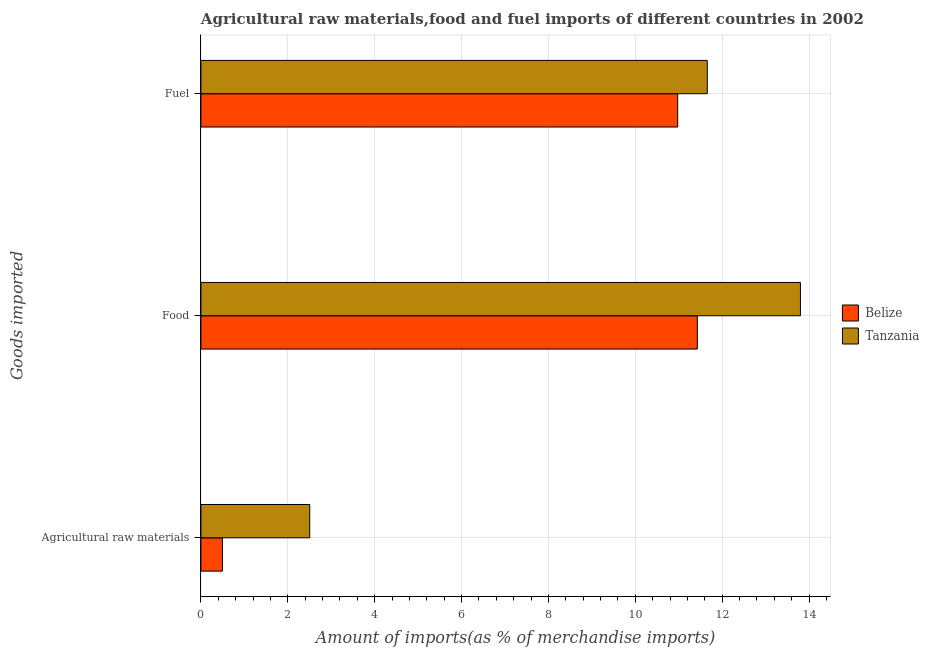Are the number of bars per tick equal to the number of legend labels?
Provide a succinct answer. Yes. How many bars are there on the 1st tick from the top?
Give a very brief answer. 2. How many bars are there on the 1st tick from the bottom?
Offer a terse response. 2. What is the label of the 2nd group of bars from the top?
Keep it short and to the point. Food. What is the percentage of fuel imports in Belize?
Ensure brevity in your answer.  10.98. Across all countries, what is the maximum percentage of food imports?
Make the answer very short. 13.8. Across all countries, what is the minimum percentage of raw materials imports?
Your answer should be very brief. 0.5. In which country was the percentage of raw materials imports maximum?
Make the answer very short. Tanzania. In which country was the percentage of food imports minimum?
Give a very brief answer. Belize. What is the total percentage of fuel imports in the graph?
Your answer should be compact. 22.63. What is the difference between the percentage of food imports in Belize and that in Tanzania?
Keep it short and to the point. -2.37. What is the difference between the percentage of food imports in Belize and the percentage of raw materials imports in Tanzania?
Make the answer very short. 8.92. What is the average percentage of raw materials imports per country?
Your response must be concise. 1.5. What is the difference between the percentage of fuel imports and percentage of raw materials imports in Belize?
Your response must be concise. 10.48. In how many countries, is the percentage of raw materials imports greater than 3.6 %?
Offer a terse response. 0. What is the ratio of the percentage of fuel imports in Belize to that in Tanzania?
Offer a terse response. 0.94. What is the difference between the highest and the second highest percentage of fuel imports?
Offer a terse response. 0.68. What is the difference between the highest and the lowest percentage of food imports?
Your answer should be very brief. 2.37. In how many countries, is the percentage of fuel imports greater than the average percentage of fuel imports taken over all countries?
Provide a succinct answer. 1. What does the 1st bar from the top in Food represents?
Give a very brief answer. Tanzania. What does the 1st bar from the bottom in Agricultural raw materials represents?
Provide a short and direct response. Belize. Is it the case that in every country, the sum of the percentage of raw materials imports and percentage of food imports is greater than the percentage of fuel imports?
Offer a very short reply. Yes. How many bars are there?
Offer a very short reply. 6. Are the values on the major ticks of X-axis written in scientific E-notation?
Your answer should be very brief. No. Where does the legend appear in the graph?
Your answer should be compact. Center right. How are the legend labels stacked?
Offer a terse response. Vertical. What is the title of the graph?
Offer a very short reply. Agricultural raw materials,food and fuel imports of different countries in 2002. Does "Zimbabwe" appear as one of the legend labels in the graph?
Provide a succinct answer. No. What is the label or title of the X-axis?
Provide a succinct answer. Amount of imports(as % of merchandise imports). What is the label or title of the Y-axis?
Provide a succinct answer. Goods imported. What is the Amount of imports(as % of merchandise imports) of Belize in Agricultural raw materials?
Your answer should be very brief. 0.5. What is the Amount of imports(as % of merchandise imports) in Tanzania in Agricultural raw materials?
Offer a very short reply. 2.51. What is the Amount of imports(as % of merchandise imports) of Belize in Food?
Offer a terse response. 11.43. What is the Amount of imports(as % of merchandise imports) in Tanzania in Food?
Your response must be concise. 13.8. What is the Amount of imports(as % of merchandise imports) of Belize in Fuel?
Make the answer very short. 10.98. What is the Amount of imports(as % of merchandise imports) of Tanzania in Fuel?
Your response must be concise. 11.66. Across all Goods imported, what is the maximum Amount of imports(as % of merchandise imports) in Belize?
Make the answer very short. 11.43. Across all Goods imported, what is the maximum Amount of imports(as % of merchandise imports) of Tanzania?
Your response must be concise. 13.8. Across all Goods imported, what is the minimum Amount of imports(as % of merchandise imports) of Belize?
Provide a short and direct response. 0.5. Across all Goods imported, what is the minimum Amount of imports(as % of merchandise imports) in Tanzania?
Keep it short and to the point. 2.51. What is the total Amount of imports(as % of merchandise imports) of Belize in the graph?
Keep it short and to the point. 22.9. What is the total Amount of imports(as % of merchandise imports) of Tanzania in the graph?
Give a very brief answer. 27.96. What is the difference between the Amount of imports(as % of merchandise imports) in Belize in Agricultural raw materials and that in Food?
Ensure brevity in your answer.  -10.93. What is the difference between the Amount of imports(as % of merchandise imports) in Tanzania in Agricultural raw materials and that in Food?
Give a very brief answer. -11.3. What is the difference between the Amount of imports(as % of merchandise imports) in Belize in Agricultural raw materials and that in Fuel?
Provide a succinct answer. -10.48. What is the difference between the Amount of imports(as % of merchandise imports) in Tanzania in Agricultural raw materials and that in Fuel?
Provide a succinct answer. -9.15. What is the difference between the Amount of imports(as % of merchandise imports) in Belize in Food and that in Fuel?
Your answer should be compact. 0.45. What is the difference between the Amount of imports(as % of merchandise imports) in Tanzania in Food and that in Fuel?
Give a very brief answer. 2.15. What is the difference between the Amount of imports(as % of merchandise imports) in Belize in Agricultural raw materials and the Amount of imports(as % of merchandise imports) in Tanzania in Food?
Offer a very short reply. -13.31. What is the difference between the Amount of imports(as % of merchandise imports) in Belize in Agricultural raw materials and the Amount of imports(as % of merchandise imports) in Tanzania in Fuel?
Give a very brief answer. -11.16. What is the difference between the Amount of imports(as % of merchandise imports) in Belize in Food and the Amount of imports(as % of merchandise imports) in Tanzania in Fuel?
Ensure brevity in your answer.  -0.23. What is the average Amount of imports(as % of merchandise imports) in Belize per Goods imported?
Your response must be concise. 7.63. What is the average Amount of imports(as % of merchandise imports) in Tanzania per Goods imported?
Keep it short and to the point. 9.32. What is the difference between the Amount of imports(as % of merchandise imports) in Belize and Amount of imports(as % of merchandise imports) in Tanzania in Agricultural raw materials?
Your response must be concise. -2.01. What is the difference between the Amount of imports(as % of merchandise imports) in Belize and Amount of imports(as % of merchandise imports) in Tanzania in Food?
Keep it short and to the point. -2.37. What is the difference between the Amount of imports(as % of merchandise imports) of Belize and Amount of imports(as % of merchandise imports) of Tanzania in Fuel?
Keep it short and to the point. -0.68. What is the ratio of the Amount of imports(as % of merchandise imports) of Belize in Agricultural raw materials to that in Food?
Make the answer very short. 0.04. What is the ratio of the Amount of imports(as % of merchandise imports) in Tanzania in Agricultural raw materials to that in Food?
Your answer should be very brief. 0.18. What is the ratio of the Amount of imports(as % of merchandise imports) of Belize in Agricultural raw materials to that in Fuel?
Ensure brevity in your answer.  0.05. What is the ratio of the Amount of imports(as % of merchandise imports) in Tanzania in Agricultural raw materials to that in Fuel?
Keep it short and to the point. 0.21. What is the ratio of the Amount of imports(as % of merchandise imports) of Belize in Food to that in Fuel?
Give a very brief answer. 1.04. What is the ratio of the Amount of imports(as % of merchandise imports) in Tanzania in Food to that in Fuel?
Your response must be concise. 1.18. What is the difference between the highest and the second highest Amount of imports(as % of merchandise imports) in Belize?
Your answer should be compact. 0.45. What is the difference between the highest and the second highest Amount of imports(as % of merchandise imports) of Tanzania?
Offer a very short reply. 2.15. What is the difference between the highest and the lowest Amount of imports(as % of merchandise imports) of Belize?
Ensure brevity in your answer.  10.93. What is the difference between the highest and the lowest Amount of imports(as % of merchandise imports) in Tanzania?
Give a very brief answer. 11.3. 